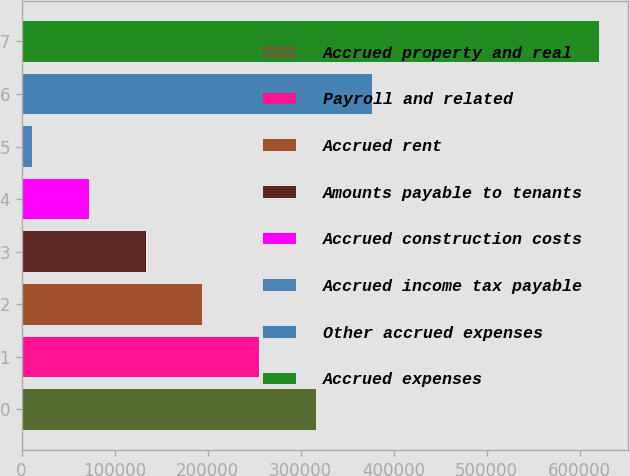Convert chart. <chart><loc_0><loc_0><loc_500><loc_500><bar_chart><fcel>Accrued property and real<fcel>Payroll and related<fcel>Accrued rent<fcel>Amounts payable to tenants<fcel>Accrued construction costs<fcel>Accrued income tax payable<fcel>Other accrued expenses<fcel>Accrued expenses<nl><fcel>316057<fcel>255156<fcel>194255<fcel>133353<fcel>72452.2<fcel>11551<fcel>376958<fcel>620563<nl></chart> 